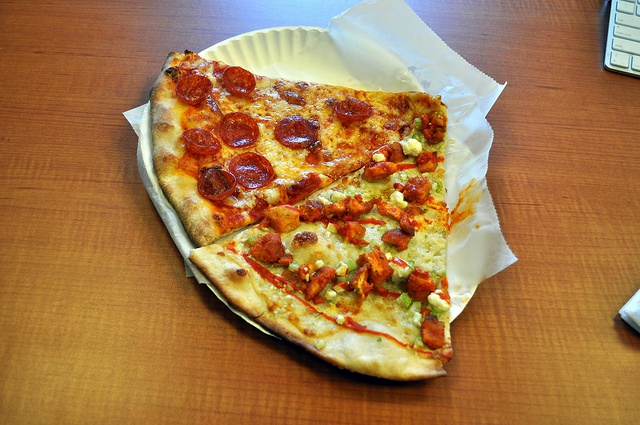Describe the objects in this image and their specific colors. I can see dining table in brown, tan, khaki, and maroon tones, pizza in maroon, khaki, and brown tones, pizza in maroon, brown, and orange tones, and keyboard in maroon, lightblue, beige, teal, and darkgray tones in this image. 